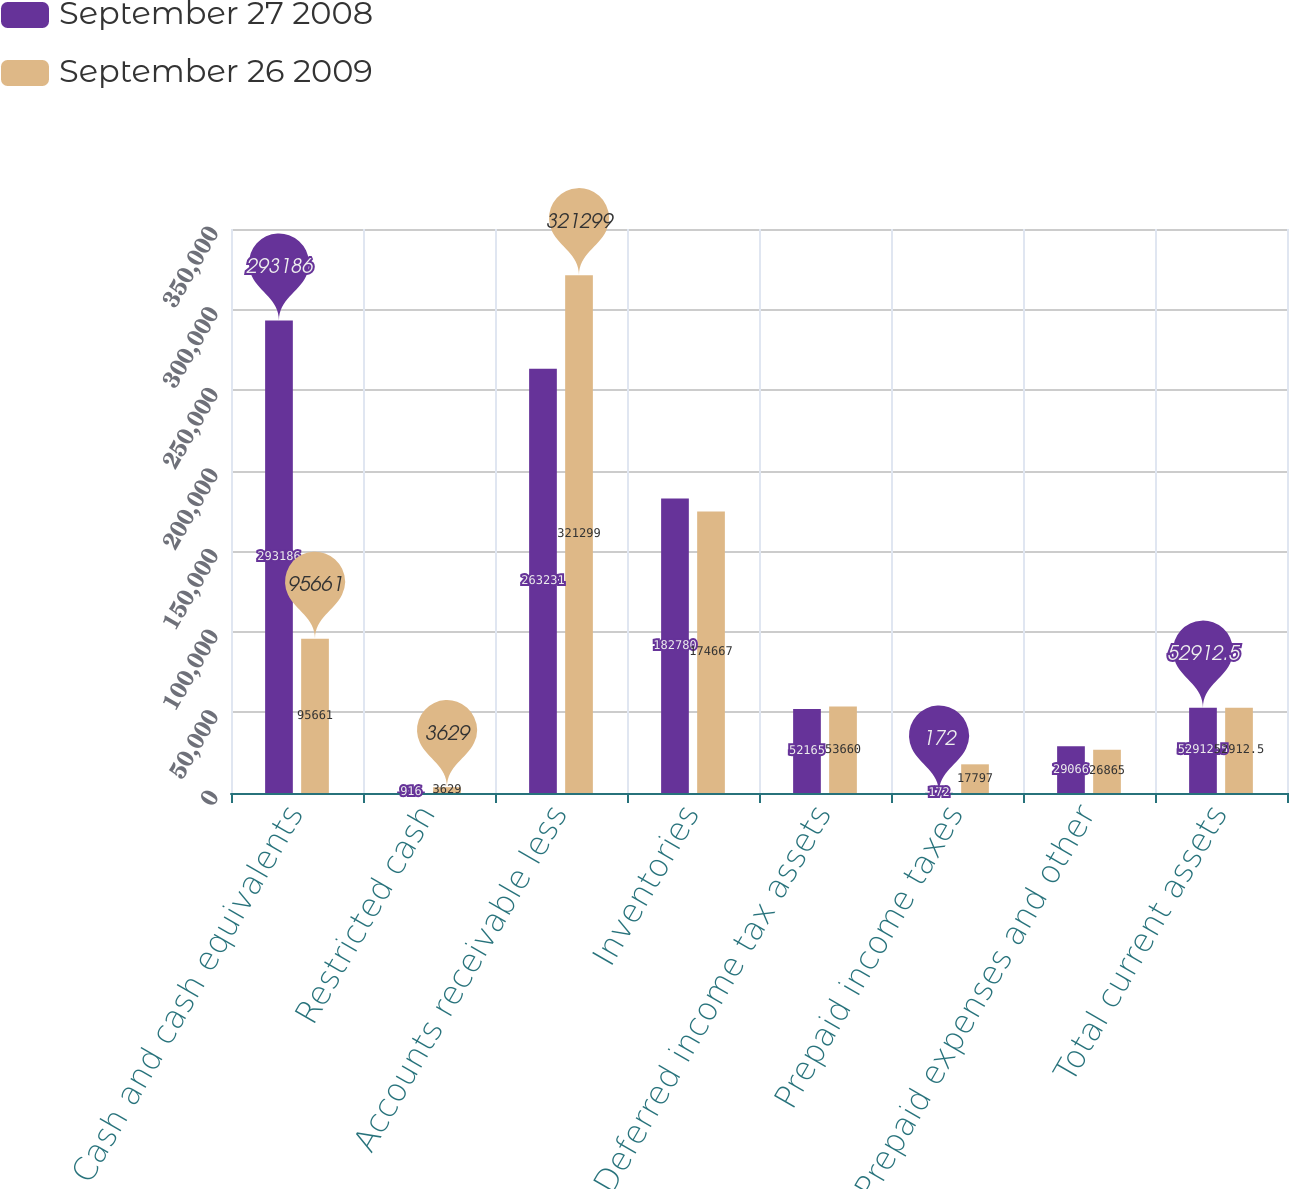Convert chart to OTSL. <chart><loc_0><loc_0><loc_500><loc_500><stacked_bar_chart><ecel><fcel>Cash and cash equivalents<fcel>Restricted cash<fcel>Accounts receivable less<fcel>Inventories<fcel>Deferred income tax assets<fcel>Prepaid income taxes<fcel>Prepaid expenses and other<fcel>Total current assets<nl><fcel>September 27 2008<fcel>293186<fcel>916<fcel>263231<fcel>182780<fcel>52165<fcel>172<fcel>29066<fcel>52912.5<nl><fcel>September 26 2009<fcel>95661<fcel>3629<fcel>321299<fcel>174667<fcel>53660<fcel>17797<fcel>26865<fcel>52912.5<nl></chart> 